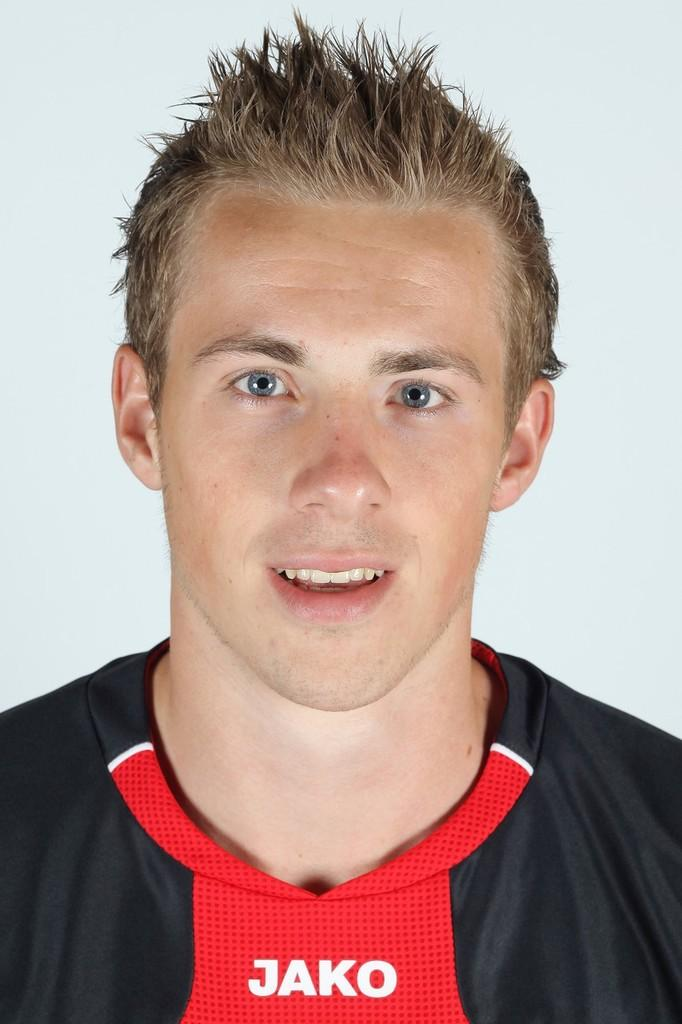Provide a one-sentence caption for the provided image. a young man wearing a  black and red JAKO jersey. 